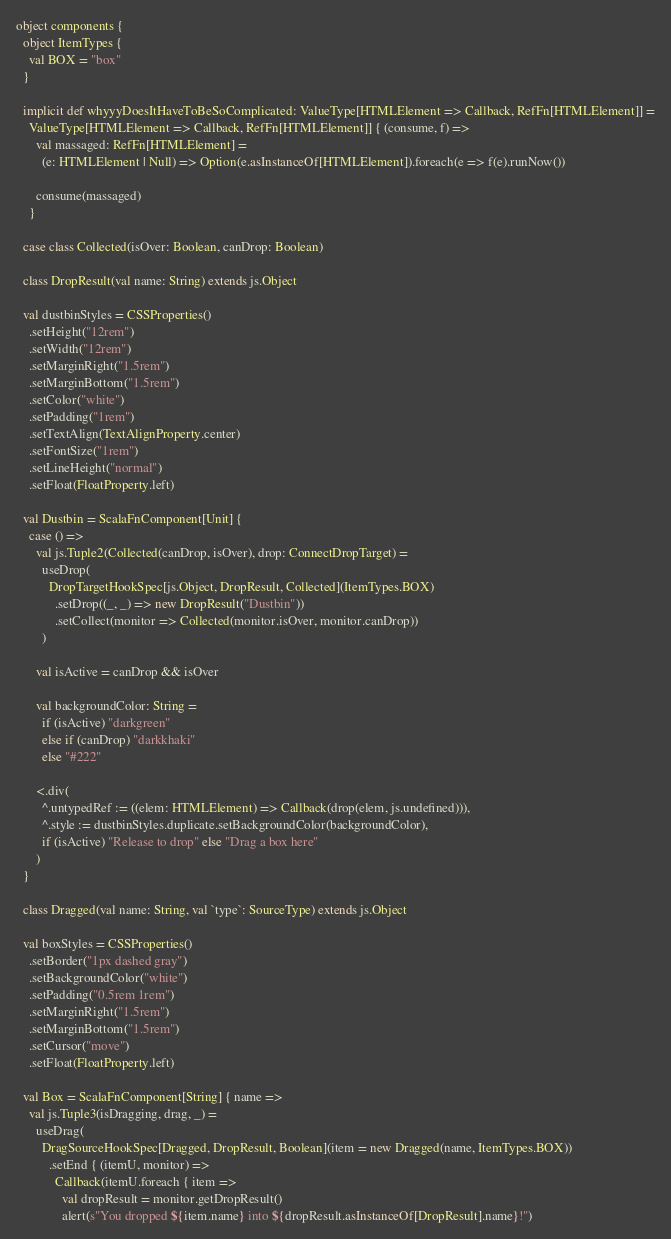Convert code to text. <code><loc_0><loc_0><loc_500><loc_500><_Scala_>
object components {
  object ItemTypes {
    val BOX = "box"
  }

  implicit def whyyyDoesItHaveToBeSoComplicated: ValueType[HTMLElement => Callback, RefFn[HTMLElement]] =
    ValueType[HTMLElement => Callback, RefFn[HTMLElement]] { (consume, f) =>
      val massaged: RefFn[HTMLElement] =
        (e: HTMLElement | Null) => Option(e.asInstanceOf[HTMLElement]).foreach(e => f(e).runNow())

      consume(massaged)
    }

  case class Collected(isOver: Boolean, canDrop: Boolean)

  class DropResult(val name: String) extends js.Object

  val dustbinStyles = CSSProperties()
    .setHeight("12rem")
    .setWidth("12rem")
    .setMarginRight("1.5rem")
    .setMarginBottom("1.5rem")
    .setColor("white")
    .setPadding("1rem")
    .setTextAlign(TextAlignProperty.center)
    .setFontSize("1rem")
    .setLineHeight("normal")
    .setFloat(FloatProperty.left)

  val Dustbin = ScalaFnComponent[Unit] {
    case () =>
      val js.Tuple2(Collected(canDrop, isOver), drop: ConnectDropTarget) =
        useDrop(
          DropTargetHookSpec[js.Object, DropResult, Collected](ItemTypes.BOX)
            .setDrop((_, _) => new DropResult("Dustbin"))
            .setCollect(monitor => Collected(monitor.isOver, monitor.canDrop))
        )

      val isActive = canDrop && isOver

      val backgroundColor: String =
        if (isActive) "darkgreen"
        else if (canDrop) "darkkhaki"
        else "#222"

      <.div(
        ^.untypedRef := ((elem: HTMLElement) => Callback(drop(elem, js.undefined))),
        ^.style := dustbinStyles.duplicate.setBackgroundColor(backgroundColor),
        if (isActive) "Release to drop" else "Drag a box here"
      )
  }

  class Dragged(val name: String, val `type`: SourceType) extends js.Object

  val boxStyles = CSSProperties()
    .setBorder("1px dashed gray")
    .setBackgroundColor("white")
    .setPadding("0.5rem 1rem")
    .setMarginRight("1.5rem")
    .setMarginBottom("1.5rem")
    .setCursor("move")
    .setFloat(FloatProperty.left)

  val Box = ScalaFnComponent[String] { name =>
    val js.Tuple3(isDragging, drag, _) =
      useDrag(
        DragSourceHookSpec[Dragged, DropResult, Boolean](item = new Dragged(name, ItemTypes.BOX))
          .setEnd { (itemU, monitor) =>
            Callback(itemU.foreach { item =>
              val dropResult = monitor.getDropResult()
              alert(s"You dropped ${item.name} into ${dropResult.asInstanceOf[DropResult].name}!")</code> 